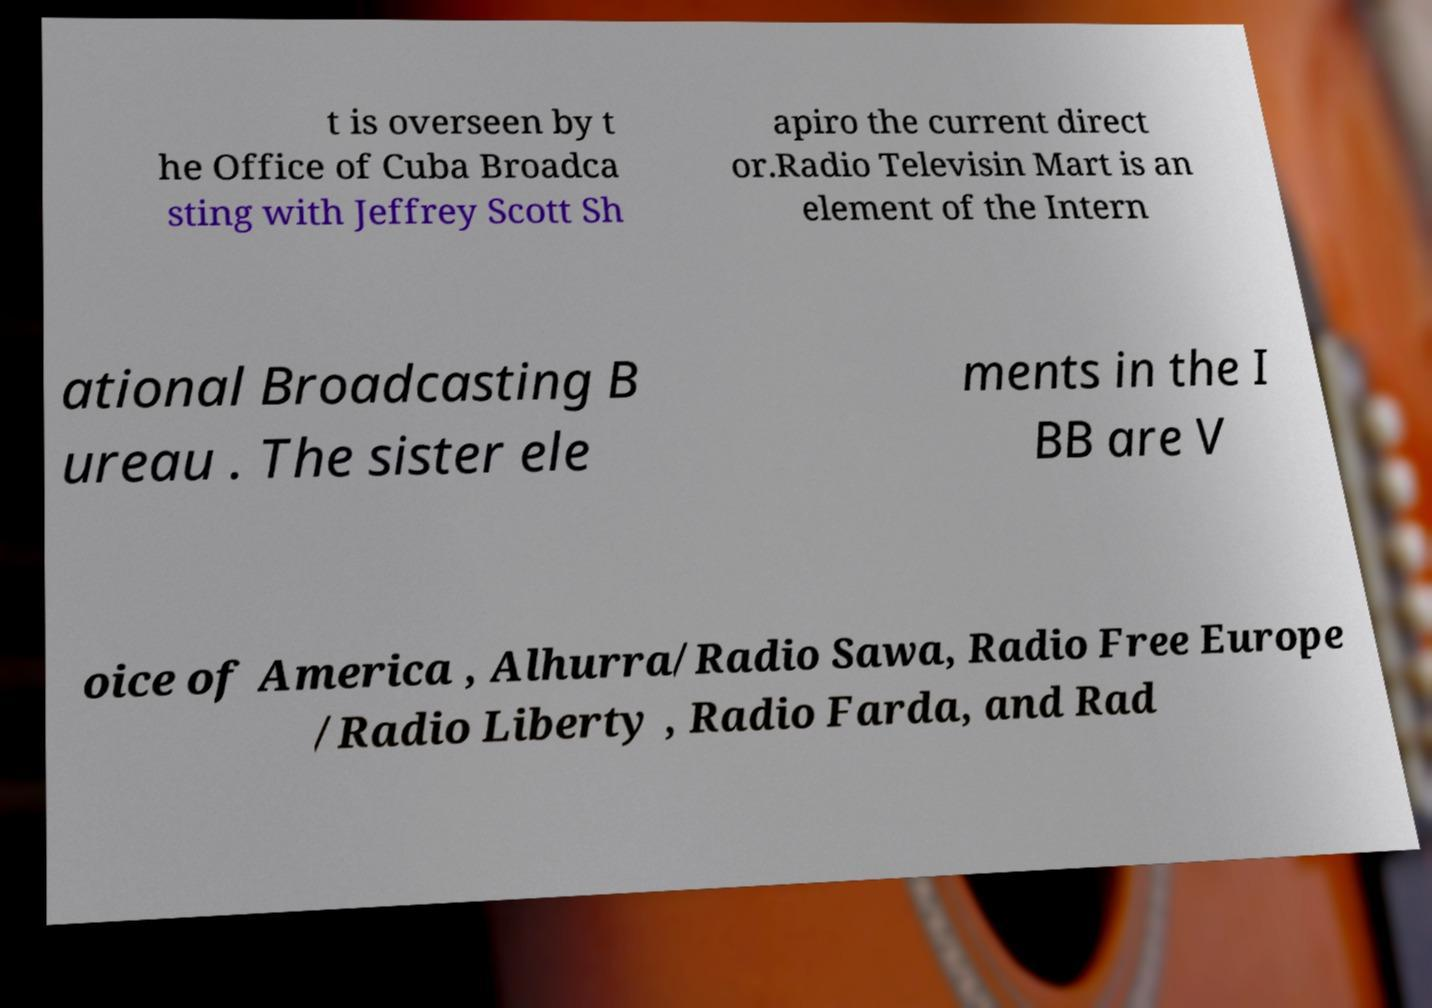Please read and relay the text visible in this image. What does it say? t is overseen by t he Office of Cuba Broadca sting with Jeffrey Scott Sh apiro the current direct or.Radio Televisin Mart is an element of the Intern ational Broadcasting B ureau . The sister ele ments in the I BB are V oice of America , Alhurra/Radio Sawa, Radio Free Europe /Radio Liberty , Radio Farda, and Rad 